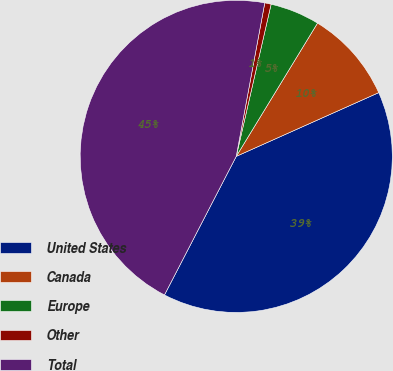Convert chart to OTSL. <chart><loc_0><loc_0><loc_500><loc_500><pie_chart><fcel>United States<fcel>Canada<fcel>Europe<fcel>Other<fcel>Total<nl><fcel>39.3%<fcel>9.59%<fcel>5.13%<fcel>0.66%<fcel>45.32%<nl></chart> 